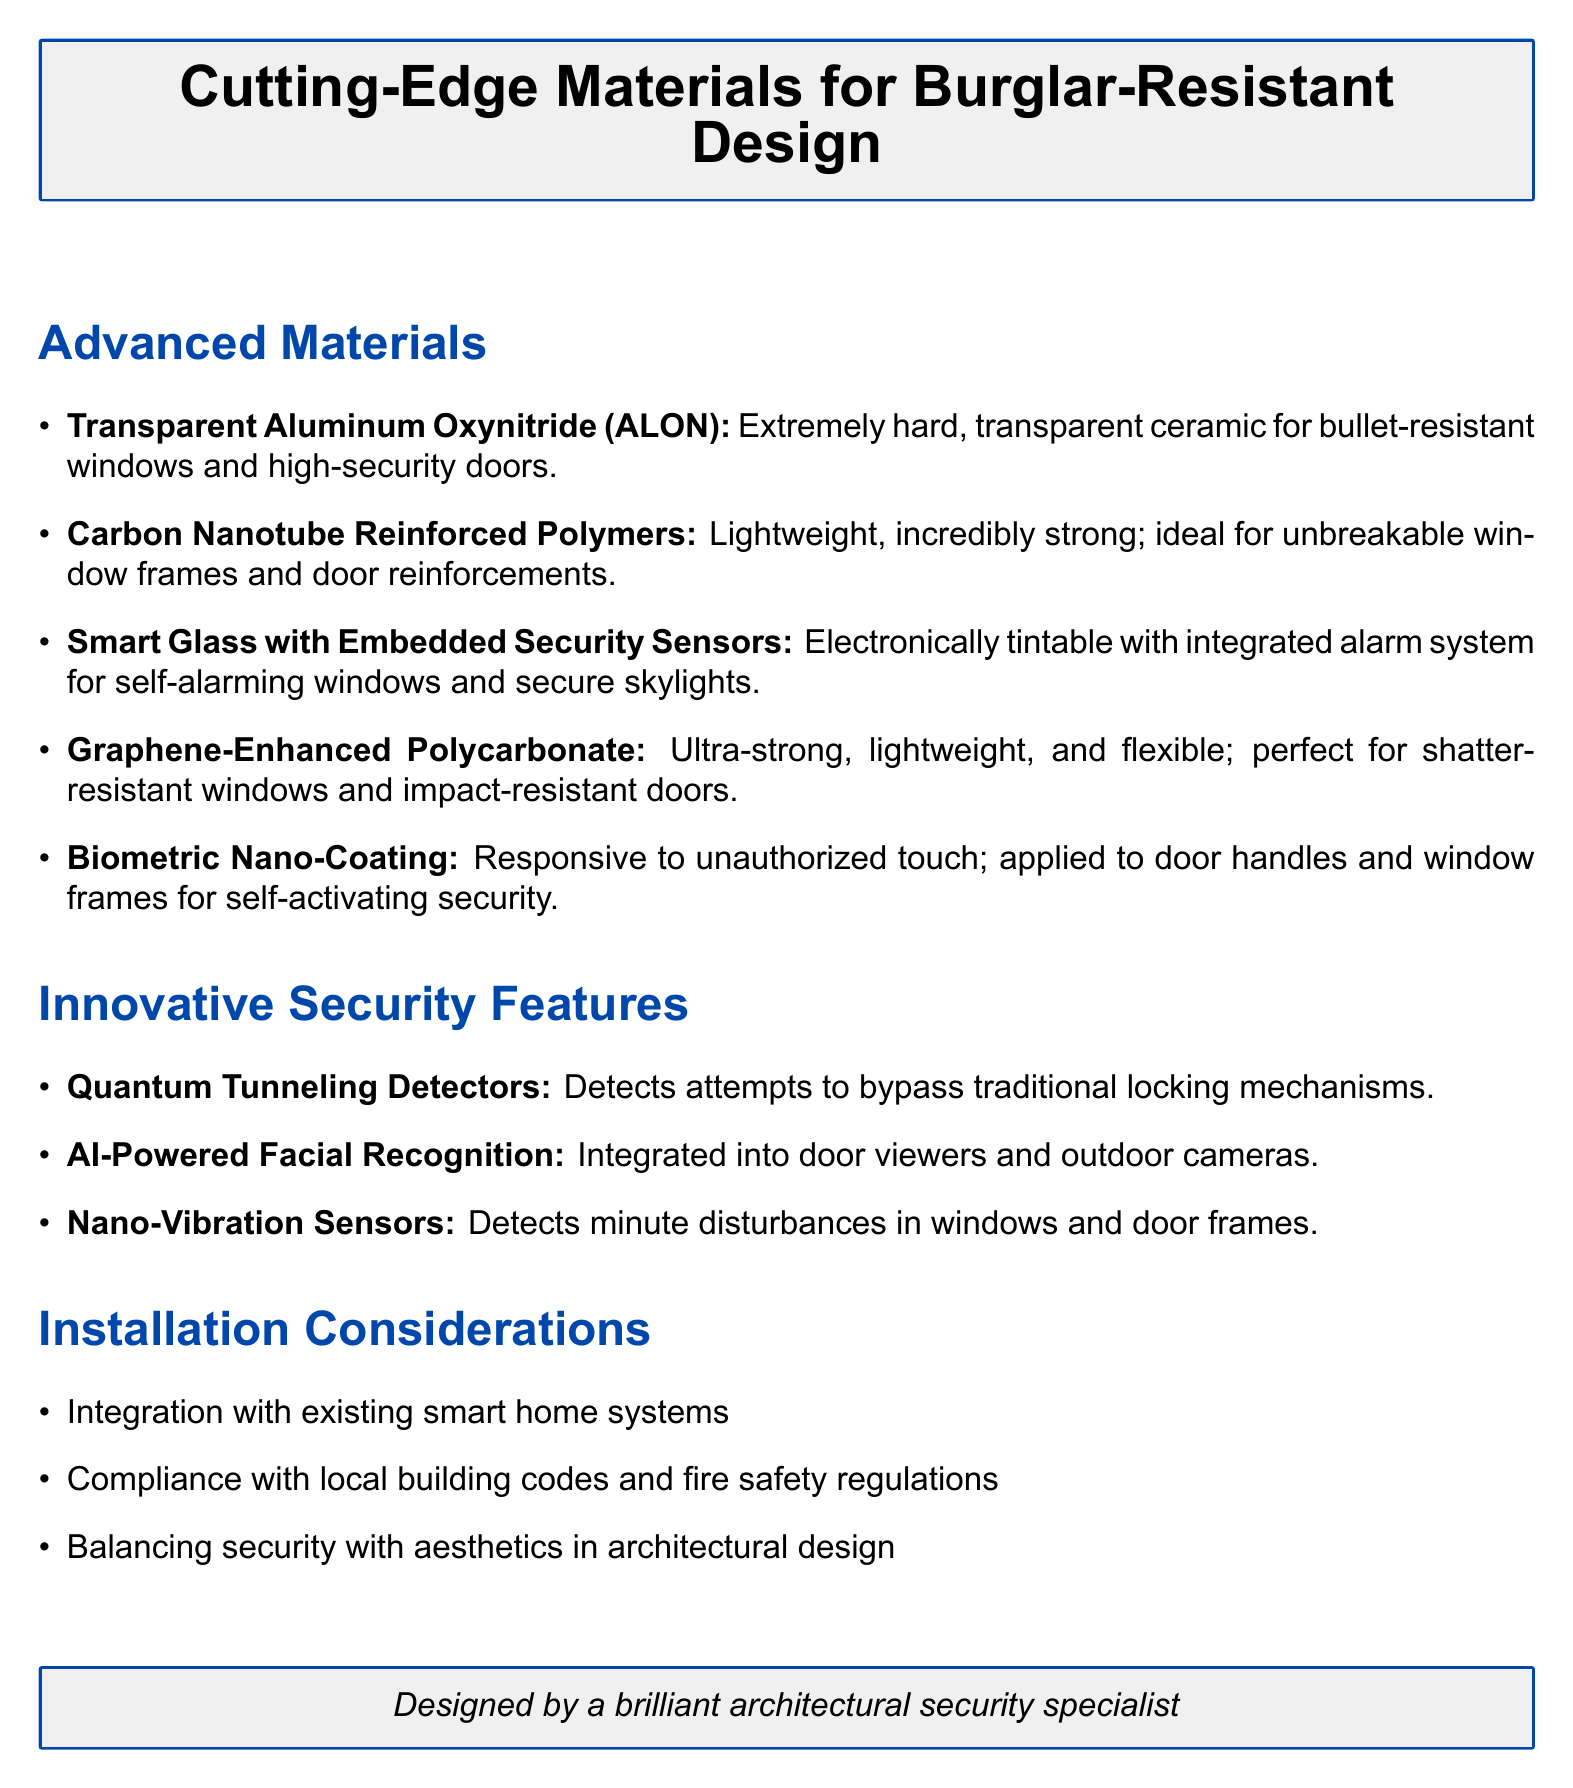What is the name of a bullet-resistant material? The document lists Transparent Aluminum Oxynitride (ALON) as a bullet-resistant material.
Answer: Transparent Aluminum Oxynitride (ALON) What is the property of Carbon Nanotube Reinforced Polymers? According to the document, they are described as lightweight and incredibly strong.
Answer: Lightweight, incredibly strong What application is mentioned for Smart Glass with Embedded Security Sensors? The document mentions that this material is used for self-alarming windows and secure skylights.
Answer: Self-alarming windows, secure skylights What innovative security feature detects attempts to bypass locking mechanisms? The document describes Quantum Tunneling Detectors as detecting attempts to bypass traditional locking mechanisms.
Answer: Quantum Tunneling Detectors What is one installation consideration mentioned in the document? The document lists multiple considerations, including the integration with existing smart home systems.
Answer: Integration with existing smart home systems How many cutting-edge materials are listed in the document? The document enumerates five different cutting-edge materials for burglar-resistant design.
Answer: Five Which material is responsive to unauthorized touch? Biometric Nano-Coating is identified in the document as the material that is responsive to unauthorized touch.
Answer: Biometric Nano-Coating What is a characteristic of Graphene-Enhanced Polycarbonate? The document describes Graphene-Enhanced Polycarbonate as ultra-strong, lightweight, and flexible.
Answer: Ultra-strong, lightweight, and flexible 